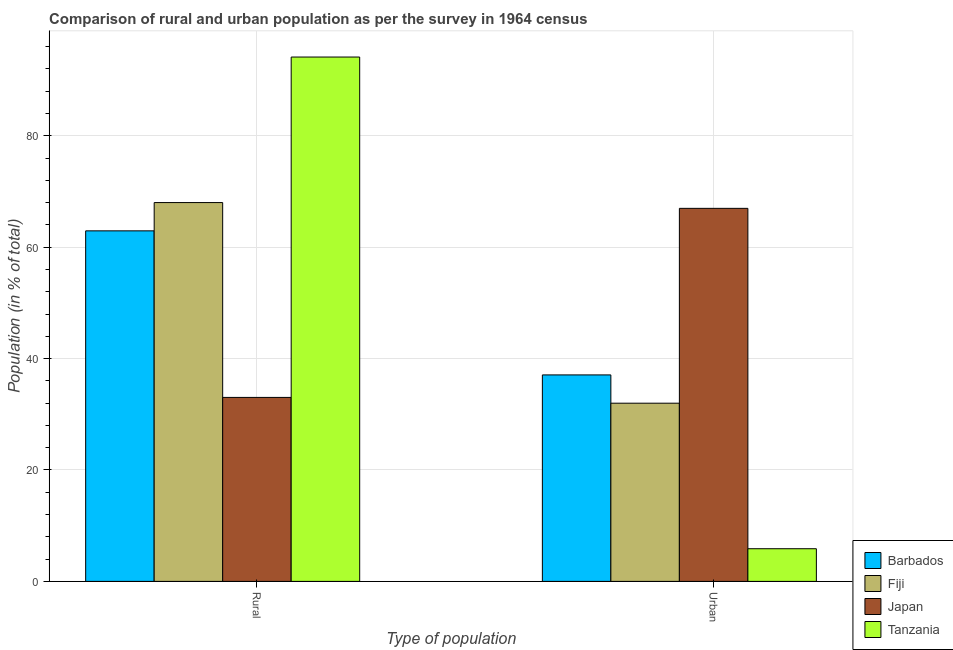How many different coloured bars are there?
Offer a very short reply. 4. How many groups of bars are there?
Provide a short and direct response. 2. Are the number of bars on each tick of the X-axis equal?
Your response must be concise. Yes. What is the label of the 1st group of bars from the left?
Give a very brief answer. Rural. What is the rural population in Barbados?
Your answer should be compact. 62.93. Across all countries, what is the maximum urban population?
Give a very brief answer. 66.97. Across all countries, what is the minimum urban population?
Keep it short and to the point. 5.87. In which country was the rural population maximum?
Your answer should be compact. Tanzania. In which country was the rural population minimum?
Provide a succinct answer. Japan. What is the total rural population in the graph?
Offer a very short reply. 258.1. What is the difference between the rural population in Japan and that in Fiji?
Your response must be concise. -34.98. What is the difference between the urban population in Barbados and the rural population in Japan?
Offer a terse response. 4.04. What is the average urban population per country?
Keep it short and to the point. 35.47. What is the difference between the rural population and urban population in Barbados?
Offer a very short reply. 25.86. In how many countries, is the urban population greater than 24 %?
Your answer should be very brief. 3. What is the ratio of the urban population in Tanzania to that in Barbados?
Offer a terse response. 0.16. Is the urban population in Barbados less than that in Japan?
Give a very brief answer. Yes. What does the 2nd bar from the left in Urban represents?
Make the answer very short. Fiji. Are all the bars in the graph horizontal?
Your answer should be compact. No. What is the difference between two consecutive major ticks on the Y-axis?
Keep it short and to the point. 20. Does the graph contain any zero values?
Offer a very short reply. No. Does the graph contain grids?
Keep it short and to the point. Yes. How many legend labels are there?
Ensure brevity in your answer.  4. What is the title of the graph?
Provide a short and direct response. Comparison of rural and urban population as per the survey in 1964 census. Does "Kazakhstan" appear as one of the legend labels in the graph?
Keep it short and to the point. No. What is the label or title of the X-axis?
Provide a short and direct response. Type of population. What is the label or title of the Y-axis?
Keep it short and to the point. Population (in % of total). What is the Population (in % of total) in Barbados in Rural?
Give a very brief answer. 62.93. What is the Population (in % of total) in Fiji in Rural?
Make the answer very short. 68.01. What is the Population (in % of total) of Japan in Rural?
Your response must be concise. 33.03. What is the Population (in % of total) in Tanzania in Rural?
Provide a succinct answer. 94.14. What is the Population (in % of total) in Barbados in Urban?
Give a very brief answer. 37.07. What is the Population (in % of total) in Fiji in Urban?
Offer a very short reply. 31.99. What is the Population (in % of total) of Japan in Urban?
Offer a terse response. 66.97. What is the Population (in % of total) in Tanzania in Urban?
Your answer should be very brief. 5.87. Across all Type of population, what is the maximum Population (in % of total) of Barbados?
Your answer should be very brief. 62.93. Across all Type of population, what is the maximum Population (in % of total) in Fiji?
Offer a terse response. 68.01. Across all Type of population, what is the maximum Population (in % of total) of Japan?
Your answer should be compact. 66.97. Across all Type of population, what is the maximum Population (in % of total) of Tanzania?
Your response must be concise. 94.14. Across all Type of population, what is the minimum Population (in % of total) of Barbados?
Offer a terse response. 37.07. Across all Type of population, what is the minimum Population (in % of total) in Fiji?
Provide a short and direct response. 31.99. Across all Type of population, what is the minimum Population (in % of total) in Japan?
Make the answer very short. 33.03. Across all Type of population, what is the minimum Population (in % of total) of Tanzania?
Give a very brief answer. 5.87. What is the total Population (in % of total) in Barbados in the graph?
Your answer should be very brief. 100. What is the total Population (in % of total) in Fiji in the graph?
Your response must be concise. 100. What is the total Population (in % of total) in Japan in the graph?
Offer a terse response. 100. What is the total Population (in % of total) in Tanzania in the graph?
Your answer should be compact. 100. What is the difference between the Population (in % of total) in Barbados in Rural and that in Urban?
Give a very brief answer. 25.86. What is the difference between the Population (in % of total) of Fiji in Rural and that in Urban?
Keep it short and to the point. 36.02. What is the difference between the Population (in % of total) of Japan in Rural and that in Urban?
Ensure brevity in your answer.  -33.94. What is the difference between the Population (in % of total) in Tanzania in Rural and that in Urban?
Your answer should be very brief. 88.27. What is the difference between the Population (in % of total) of Barbados in Rural and the Population (in % of total) of Fiji in Urban?
Make the answer very short. 30.94. What is the difference between the Population (in % of total) in Barbados in Rural and the Population (in % of total) in Japan in Urban?
Offer a terse response. -4.04. What is the difference between the Population (in % of total) of Barbados in Rural and the Population (in % of total) of Tanzania in Urban?
Your response must be concise. 57.07. What is the difference between the Population (in % of total) in Fiji in Rural and the Population (in % of total) in Tanzania in Urban?
Offer a terse response. 62.14. What is the difference between the Population (in % of total) in Japan in Rural and the Population (in % of total) in Tanzania in Urban?
Ensure brevity in your answer.  27.16. What is the average Population (in % of total) of Japan per Type of population?
Your response must be concise. 50. What is the difference between the Population (in % of total) in Barbados and Population (in % of total) in Fiji in Rural?
Give a very brief answer. -5.08. What is the difference between the Population (in % of total) of Barbados and Population (in % of total) of Japan in Rural?
Your response must be concise. 29.9. What is the difference between the Population (in % of total) in Barbados and Population (in % of total) in Tanzania in Rural?
Give a very brief answer. -31.2. What is the difference between the Population (in % of total) of Fiji and Population (in % of total) of Japan in Rural?
Provide a succinct answer. 34.98. What is the difference between the Population (in % of total) of Fiji and Population (in % of total) of Tanzania in Rural?
Keep it short and to the point. -26.13. What is the difference between the Population (in % of total) of Japan and Population (in % of total) of Tanzania in Rural?
Keep it short and to the point. -61.11. What is the difference between the Population (in % of total) of Barbados and Population (in % of total) of Fiji in Urban?
Your answer should be very brief. 5.08. What is the difference between the Population (in % of total) of Barbados and Population (in % of total) of Japan in Urban?
Provide a succinct answer. -29.9. What is the difference between the Population (in % of total) of Barbados and Population (in % of total) of Tanzania in Urban?
Your answer should be compact. 31.2. What is the difference between the Population (in % of total) in Fiji and Population (in % of total) in Japan in Urban?
Keep it short and to the point. -34.98. What is the difference between the Population (in % of total) in Fiji and Population (in % of total) in Tanzania in Urban?
Your answer should be compact. 26.13. What is the difference between the Population (in % of total) in Japan and Population (in % of total) in Tanzania in Urban?
Make the answer very short. 61.11. What is the ratio of the Population (in % of total) of Barbados in Rural to that in Urban?
Your response must be concise. 1.7. What is the ratio of the Population (in % of total) of Fiji in Rural to that in Urban?
Ensure brevity in your answer.  2.13. What is the ratio of the Population (in % of total) of Japan in Rural to that in Urban?
Keep it short and to the point. 0.49. What is the ratio of the Population (in % of total) of Tanzania in Rural to that in Urban?
Your answer should be very brief. 16.05. What is the difference between the highest and the second highest Population (in % of total) of Barbados?
Provide a succinct answer. 25.86. What is the difference between the highest and the second highest Population (in % of total) in Fiji?
Give a very brief answer. 36.02. What is the difference between the highest and the second highest Population (in % of total) of Japan?
Offer a very short reply. 33.94. What is the difference between the highest and the second highest Population (in % of total) in Tanzania?
Provide a succinct answer. 88.27. What is the difference between the highest and the lowest Population (in % of total) of Barbados?
Make the answer very short. 25.86. What is the difference between the highest and the lowest Population (in % of total) of Fiji?
Your answer should be compact. 36.02. What is the difference between the highest and the lowest Population (in % of total) in Japan?
Provide a short and direct response. 33.94. What is the difference between the highest and the lowest Population (in % of total) in Tanzania?
Ensure brevity in your answer.  88.27. 